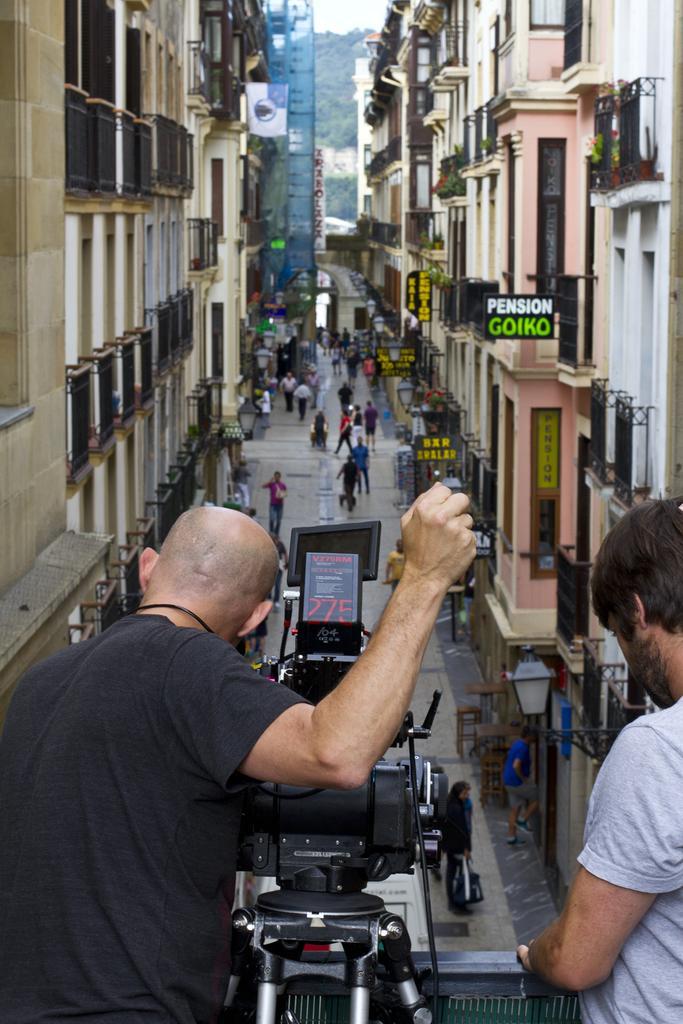Describe this image in one or two sentences. In this image there is a person wearing black color T-shirt holding a camera in his hand and at the background of the image there are persons walking and there are buildings. 